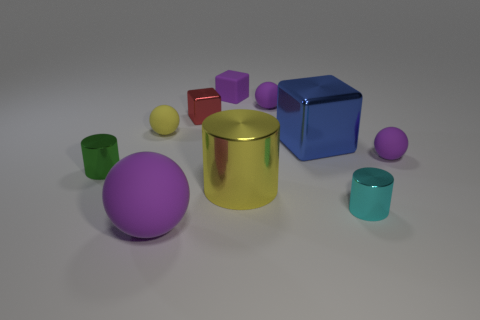What number of green shiny objects are the same size as the blue shiny cube?
Ensure brevity in your answer.  0. There is a small matte thing right of the big blue shiny cube; is it the same color as the small matte block?
Provide a short and direct response. Yes. There is a cube that is on the right side of the red metal object and behind the yellow rubber object; what material is it?
Ensure brevity in your answer.  Rubber. Is the number of cylinders greater than the number of purple matte cubes?
Provide a short and direct response. Yes. There is a large shiny object that is in front of the tiny sphere on the right side of the tiny metal cylinder that is on the right side of the large block; what is its color?
Your answer should be compact. Yellow. Do the small cylinder that is right of the green metal cylinder and the tiny green cylinder have the same material?
Make the answer very short. Yes. Is there a big rubber ball that has the same color as the tiny matte cube?
Offer a terse response. Yes. Are any tiny matte cubes visible?
Ensure brevity in your answer.  Yes. Do the yellow object behind the green cylinder and the big purple rubber object have the same size?
Your response must be concise. No. Are there fewer tiny spheres than cyan blocks?
Provide a short and direct response. No. 